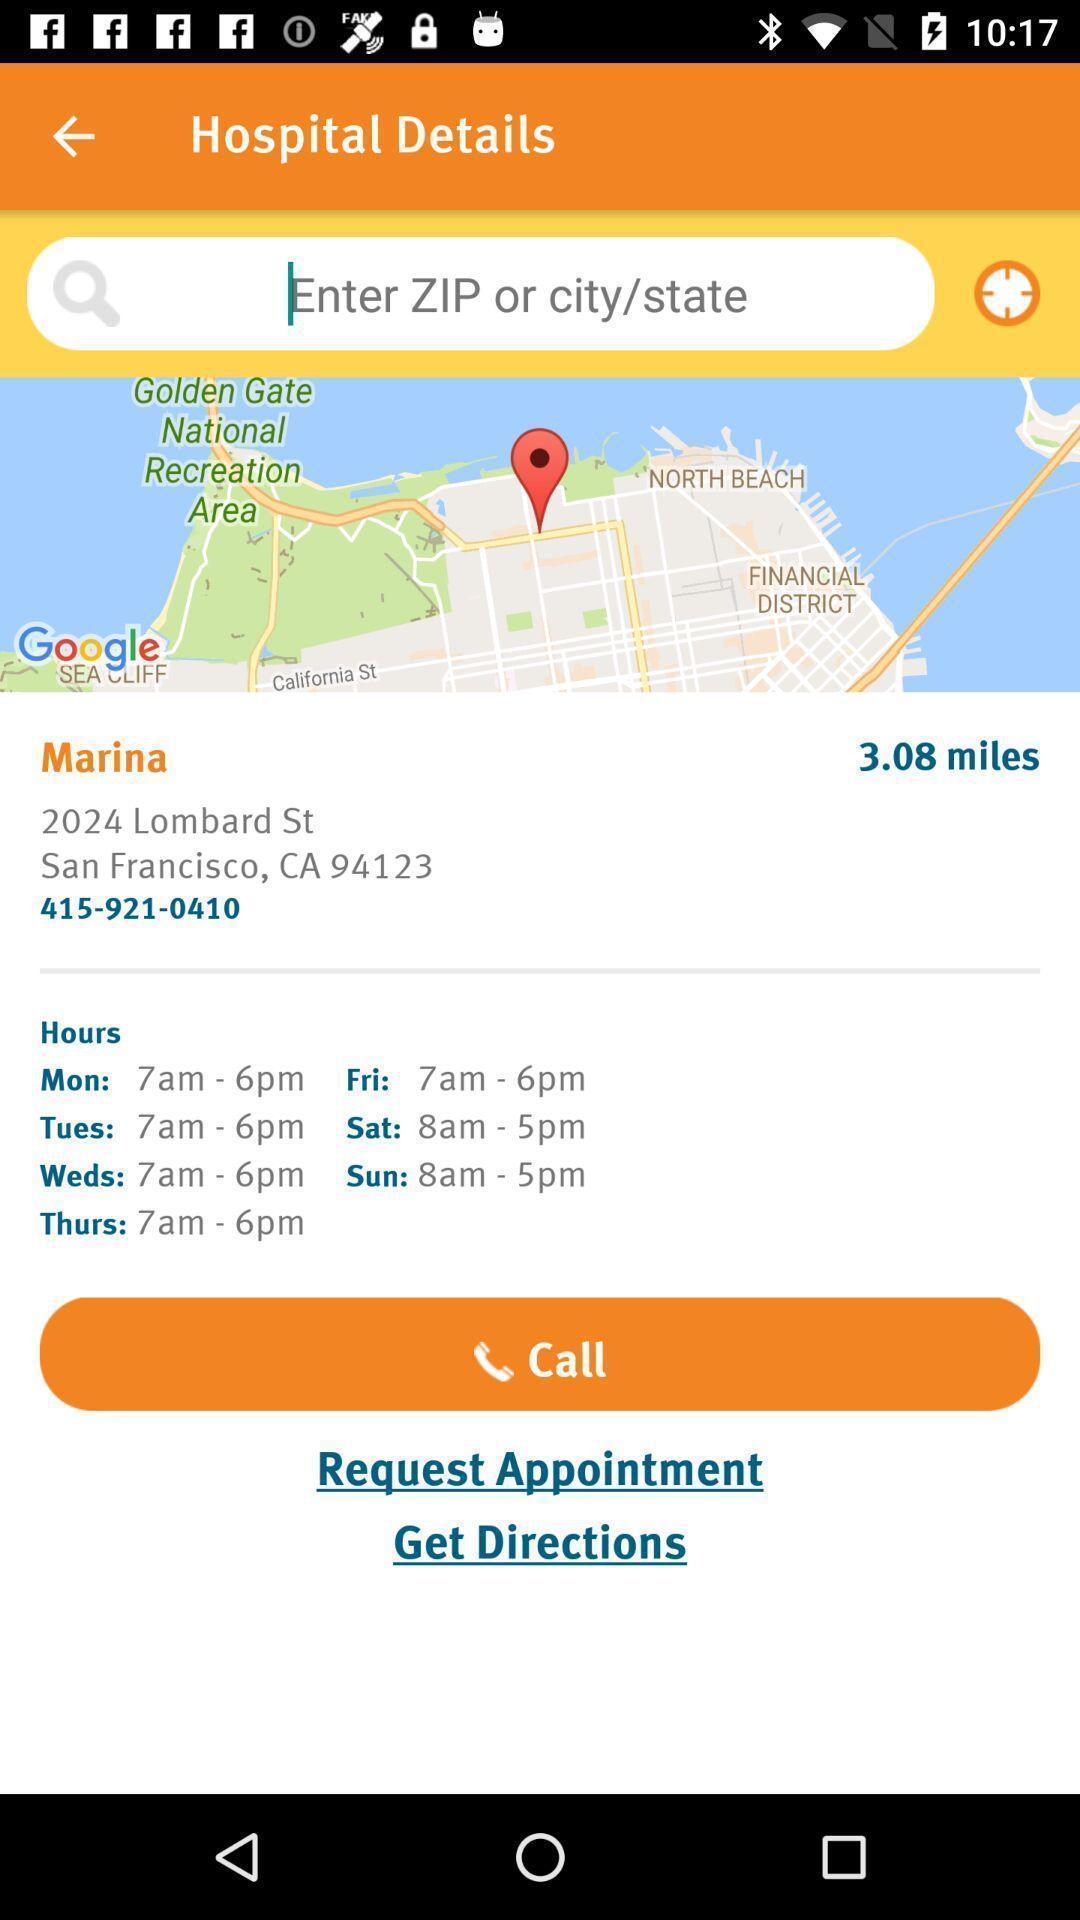Describe this image in words. Page showing hospital details in a pet hospital app. 